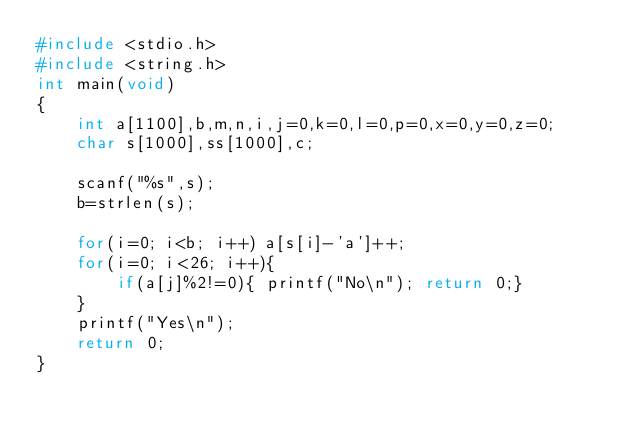Convert code to text. <code><loc_0><loc_0><loc_500><loc_500><_C_>#include <stdio.h>
#include <string.h>
int main(void)
{
    int a[1100],b,m,n,i,j=0,k=0,l=0,p=0,x=0,y=0,z=0;
    char s[1000],ss[1000],c;

    scanf("%s",s);
    b=strlen(s);

    for(i=0; i<b; i++) a[s[i]-'a']++; 
    for(i=0; i<26; i++){
        if(a[j]%2!=0){ printf("No\n"); return 0;}
    }
    printf("Yes\n");
    return 0;
}</code> 